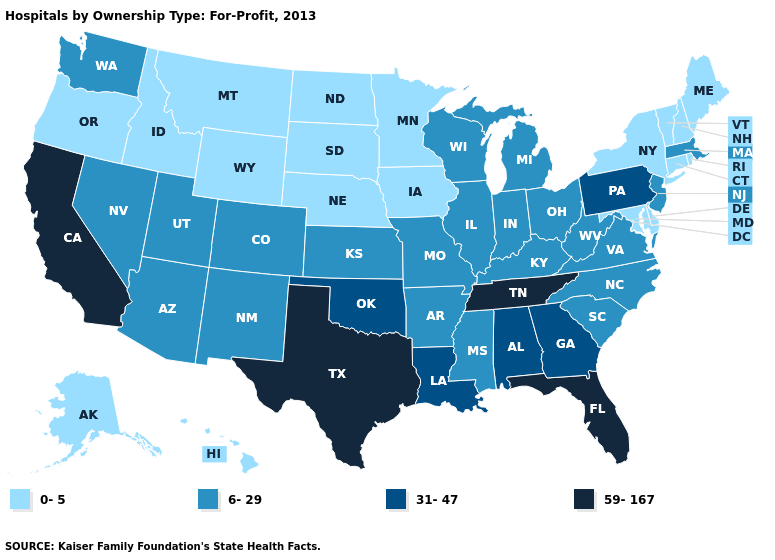Does Massachusetts have a higher value than Alabama?
Write a very short answer. No. Among the states that border Nebraska , which have the lowest value?
Give a very brief answer. Iowa, South Dakota, Wyoming. Is the legend a continuous bar?
Quick response, please. No. What is the value of Maine?
Be succinct. 0-5. What is the value of Washington?
Short answer required. 6-29. What is the value of Oregon?
Short answer required. 0-5. Which states have the lowest value in the West?
Short answer required. Alaska, Hawaii, Idaho, Montana, Oregon, Wyoming. Name the states that have a value in the range 0-5?
Write a very short answer. Alaska, Connecticut, Delaware, Hawaii, Idaho, Iowa, Maine, Maryland, Minnesota, Montana, Nebraska, New Hampshire, New York, North Dakota, Oregon, Rhode Island, South Dakota, Vermont, Wyoming. Does Indiana have the highest value in the USA?
Quick response, please. No. What is the highest value in states that border Vermont?
Answer briefly. 6-29. What is the lowest value in the USA?
Short answer required. 0-5. Name the states that have a value in the range 6-29?
Answer briefly. Arizona, Arkansas, Colorado, Illinois, Indiana, Kansas, Kentucky, Massachusetts, Michigan, Mississippi, Missouri, Nevada, New Jersey, New Mexico, North Carolina, Ohio, South Carolina, Utah, Virginia, Washington, West Virginia, Wisconsin. Does Vermont have a lower value than Texas?
Give a very brief answer. Yes. Which states have the highest value in the USA?
Concise answer only. California, Florida, Tennessee, Texas. What is the value of Mississippi?
Answer briefly. 6-29. 